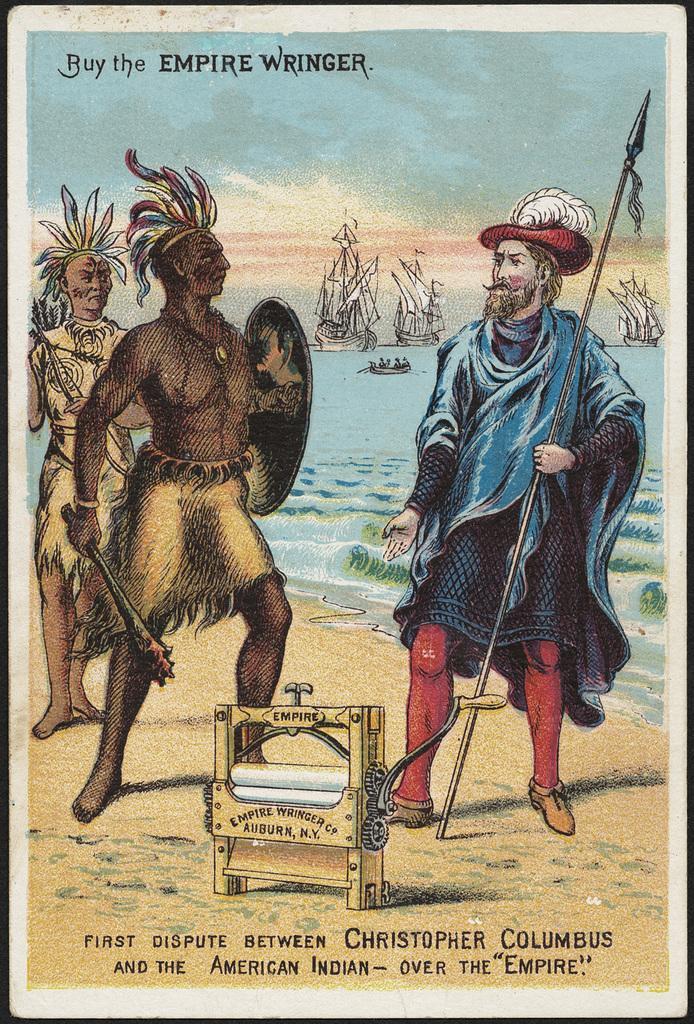In one or two sentences, can you explain what this image depicts? In the picture we can see a painting of a tribal person standing with a weapon on the sea shore and in the water we can see some boats and in the background, we can see sky with clouds and on it written as buy the empire wringer. 